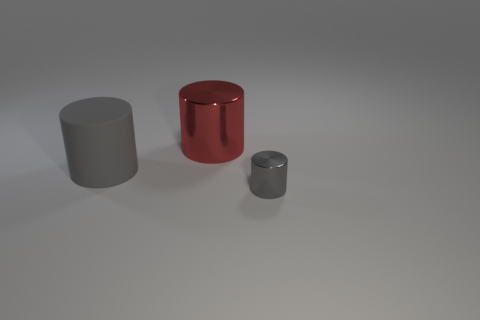Add 3 small yellow matte cylinders. How many objects exist? 6 Subtract all large red cylinders. Subtract all large cylinders. How many objects are left? 0 Add 1 gray cylinders. How many gray cylinders are left? 3 Add 3 large green matte balls. How many large green matte balls exist? 3 Subtract 1 red cylinders. How many objects are left? 2 